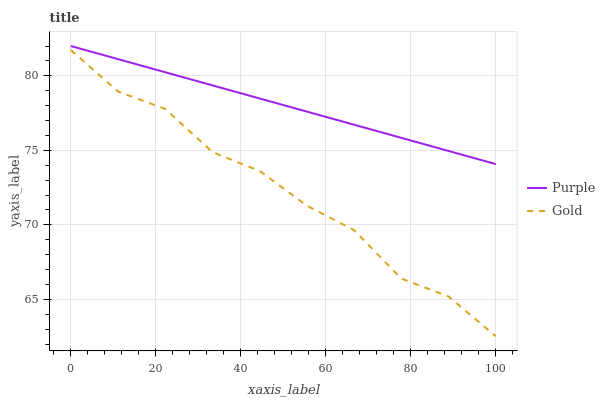Does Gold have the minimum area under the curve?
Answer yes or no. Yes. Does Purple have the maximum area under the curve?
Answer yes or no. Yes. Does Gold have the maximum area under the curve?
Answer yes or no. No. Is Purple the smoothest?
Answer yes or no. Yes. Is Gold the roughest?
Answer yes or no. Yes. Is Gold the smoothest?
Answer yes or no. No. Does Gold have the lowest value?
Answer yes or no. Yes. Does Purple have the highest value?
Answer yes or no. Yes. Does Gold have the highest value?
Answer yes or no. No. Is Gold less than Purple?
Answer yes or no. Yes. Is Purple greater than Gold?
Answer yes or no. Yes. Does Gold intersect Purple?
Answer yes or no. No. 